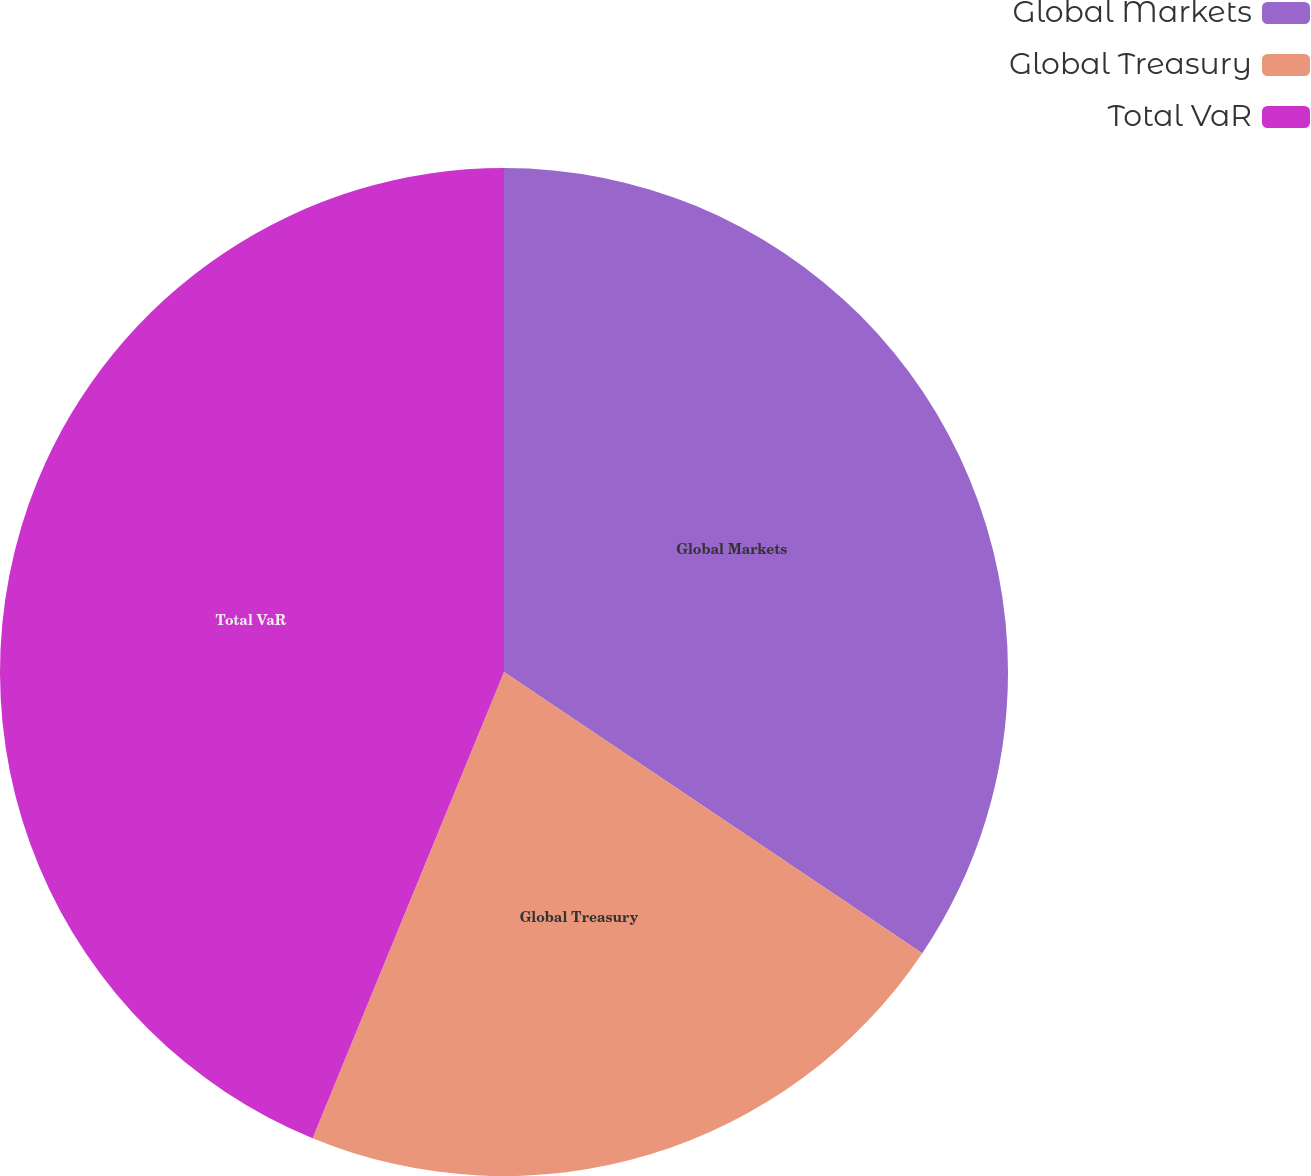Convert chart. <chart><loc_0><loc_0><loc_500><loc_500><pie_chart><fcel>Global Markets<fcel>Global Treasury<fcel>Total VaR<nl><fcel>34.42%<fcel>21.78%<fcel>43.8%<nl></chart> 